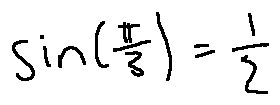<formula> <loc_0><loc_0><loc_500><loc_500>\sin ( \frac { \pi } { 3 } ) = \frac { 1 } { 2 }</formula> 